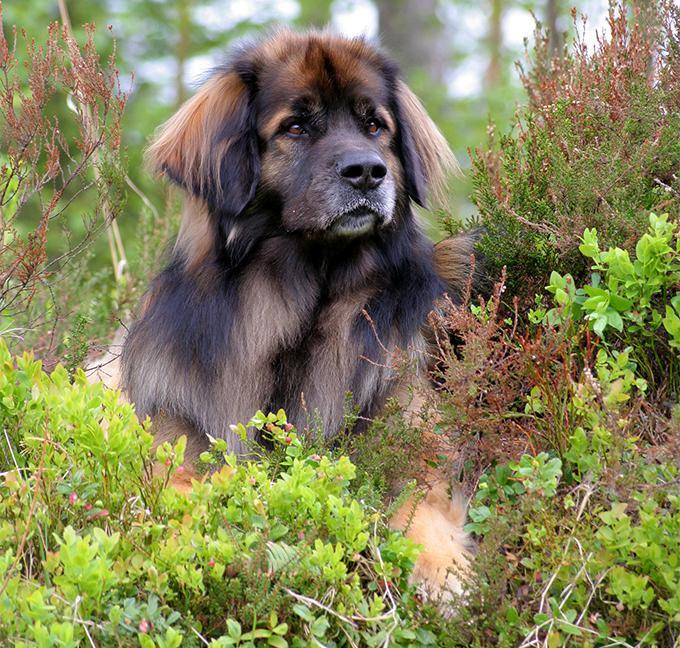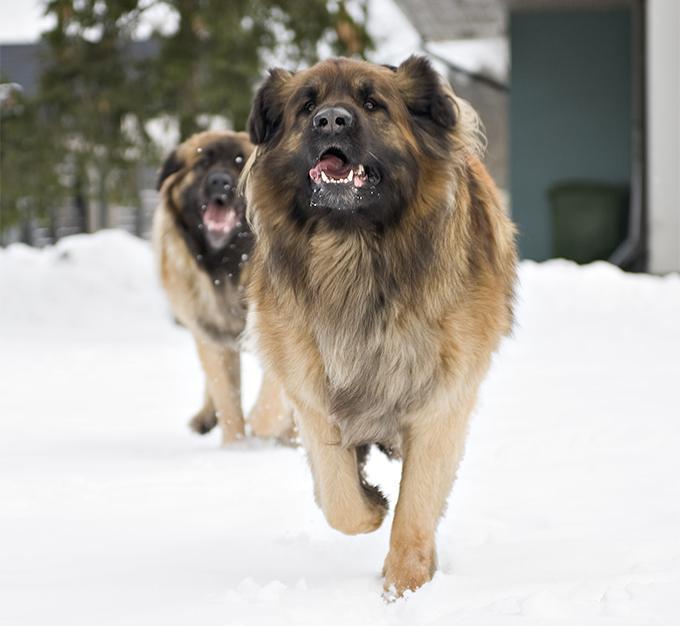The first image is the image on the left, the second image is the image on the right. Assess this claim about the two images: "One image shows a dog walking toward the camera.". Correct or not? Answer yes or no. Yes. The first image is the image on the left, the second image is the image on the right. Considering the images on both sides, is "A puppy is laying in the grass." valid? Answer yes or no. No. 